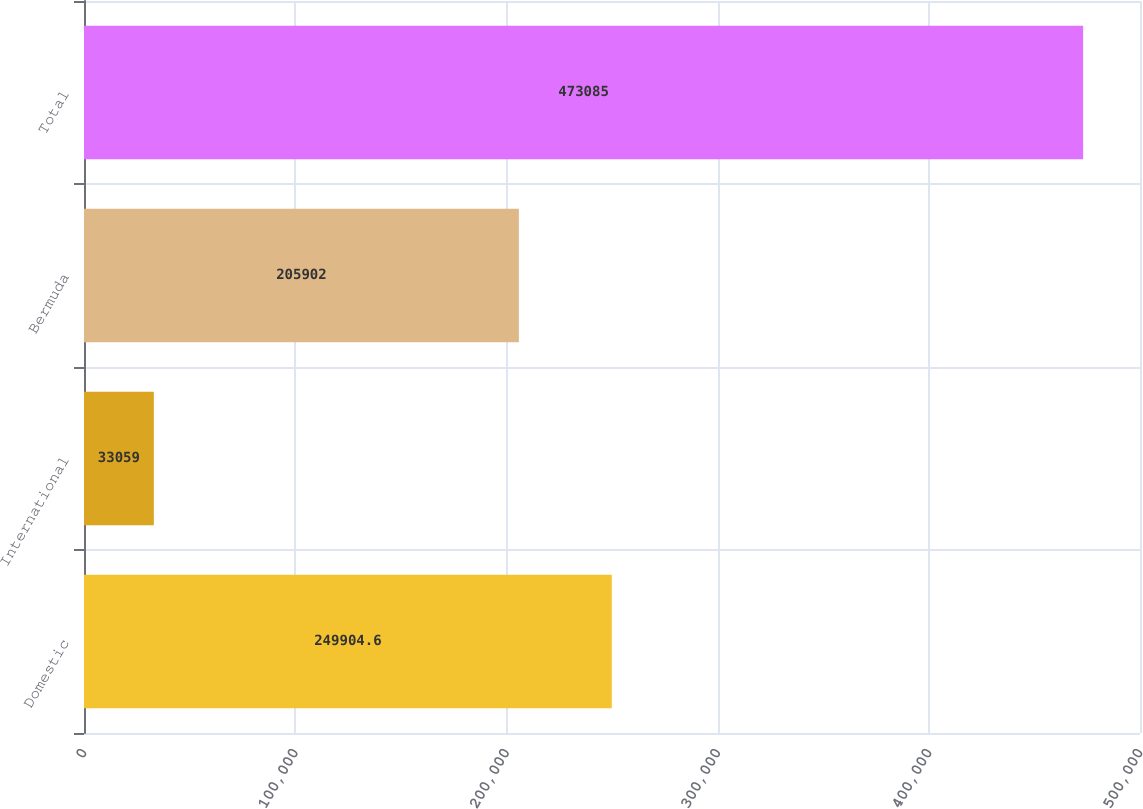<chart> <loc_0><loc_0><loc_500><loc_500><bar_chart><fcel>Domestic<fcel>International<fcel>Bermuda<fcel>Total<nl><fcel>249905<fcel>33059<fcel>205902<fcel>473085<nl></chart> 